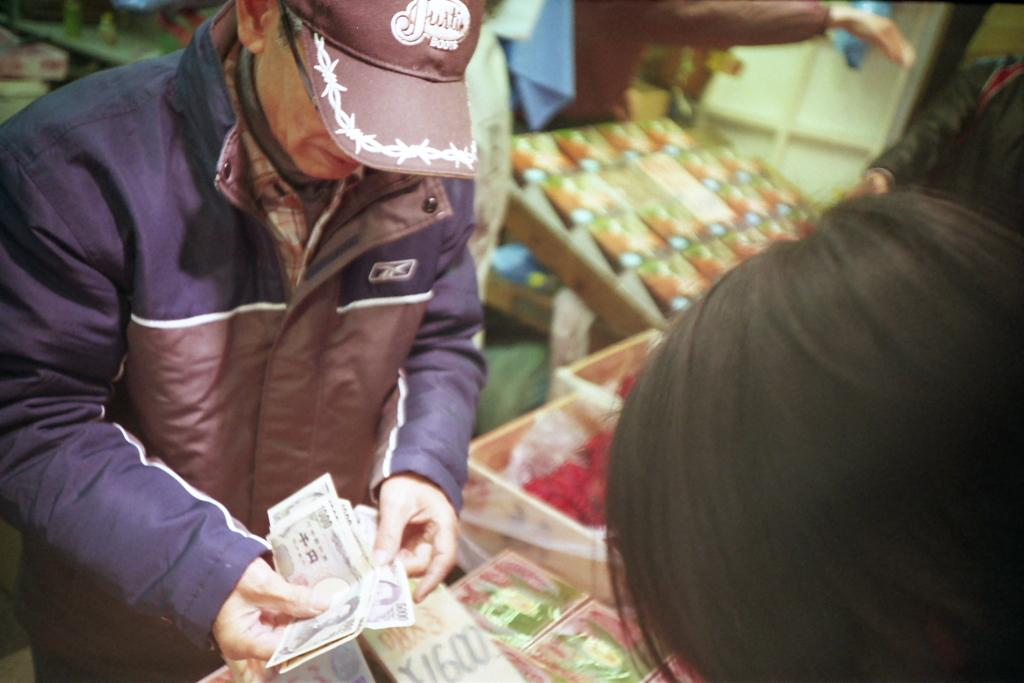What type of clothing is the person wearing on their upper body in the image? The person is wearing a jacket in the image. What type of headwear is the person wearing in the image? The person is wearing a cap in the image. What is the person holding in the image? The person is holding currency in the image. Can you describe the background of the image? The background of the image is blurred. What else can be seen in the image besides the person? There are people and things visible in the image. What type of bridge can be seen in the image? There is no bridge present in the image. How many trees are visible in the image? There are no trees visible in the image. What color is the curtain in the image? There is no curtain present in the image. 